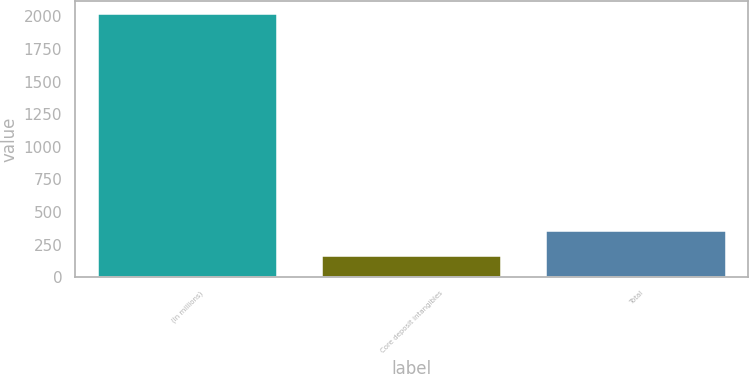<chart> <loc_0><loc_0><loc_500><loc_500><bar_chart><fcel>(In millions)<fcel>Core deposit intangibles<fcel>Total<nl><fcel>2017<fcel>165<fcel>350.2<nl></chart> 